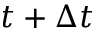Convert formula to latex. <formula><loc_0><loc_0><loc_500><loc_500>t + \Delta t</formula> 